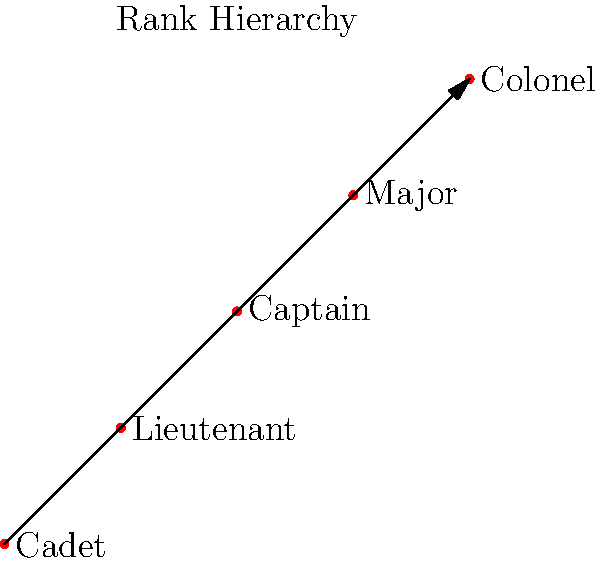In a military medical hierarchy group, the ranks are ordered as shown in the diagram. If we define the group operation * as "promotes to," such that A * B = the rank that A promotes to after B promotions, what is the result of Captain * Major? To solve this problem, we need to follow these steps:

1. Understand the group operation: A * B means the rank that A becomes after B promotions.

2. Identify the positions of Captain and Major in the hierarchy:
   Captain is at position 2 (counting from 0)
   Major is at position 3

3. Calculate the number of promotions:
   Major represents 3 promotions

4. Start from Captain (position 2) and move up 3 positions:
   2 (Captain) + 3 (promotions) = 5

5. However, there are only 5 ranks in total (0 to 4). So we need to use modular arithmetic:
   5 mod 5 = 0

6. Position 0 corresponds to Cadet in the hierarchy

Therefore, Captain * Major = Cadet, as Captain promoted 3 times (represented by Major) cycles back to Cadet in this group structure.
Answer: Cadet 